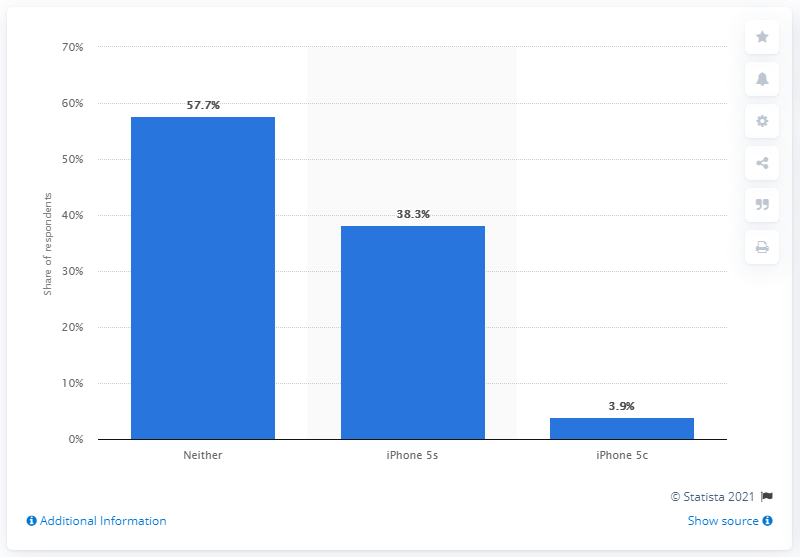Specify some key components in this picture. According to a survey, a significant percentage of Chinese people were not planning on buying the iPhone 5s and 5c. The exact percentage was 57.7%. 